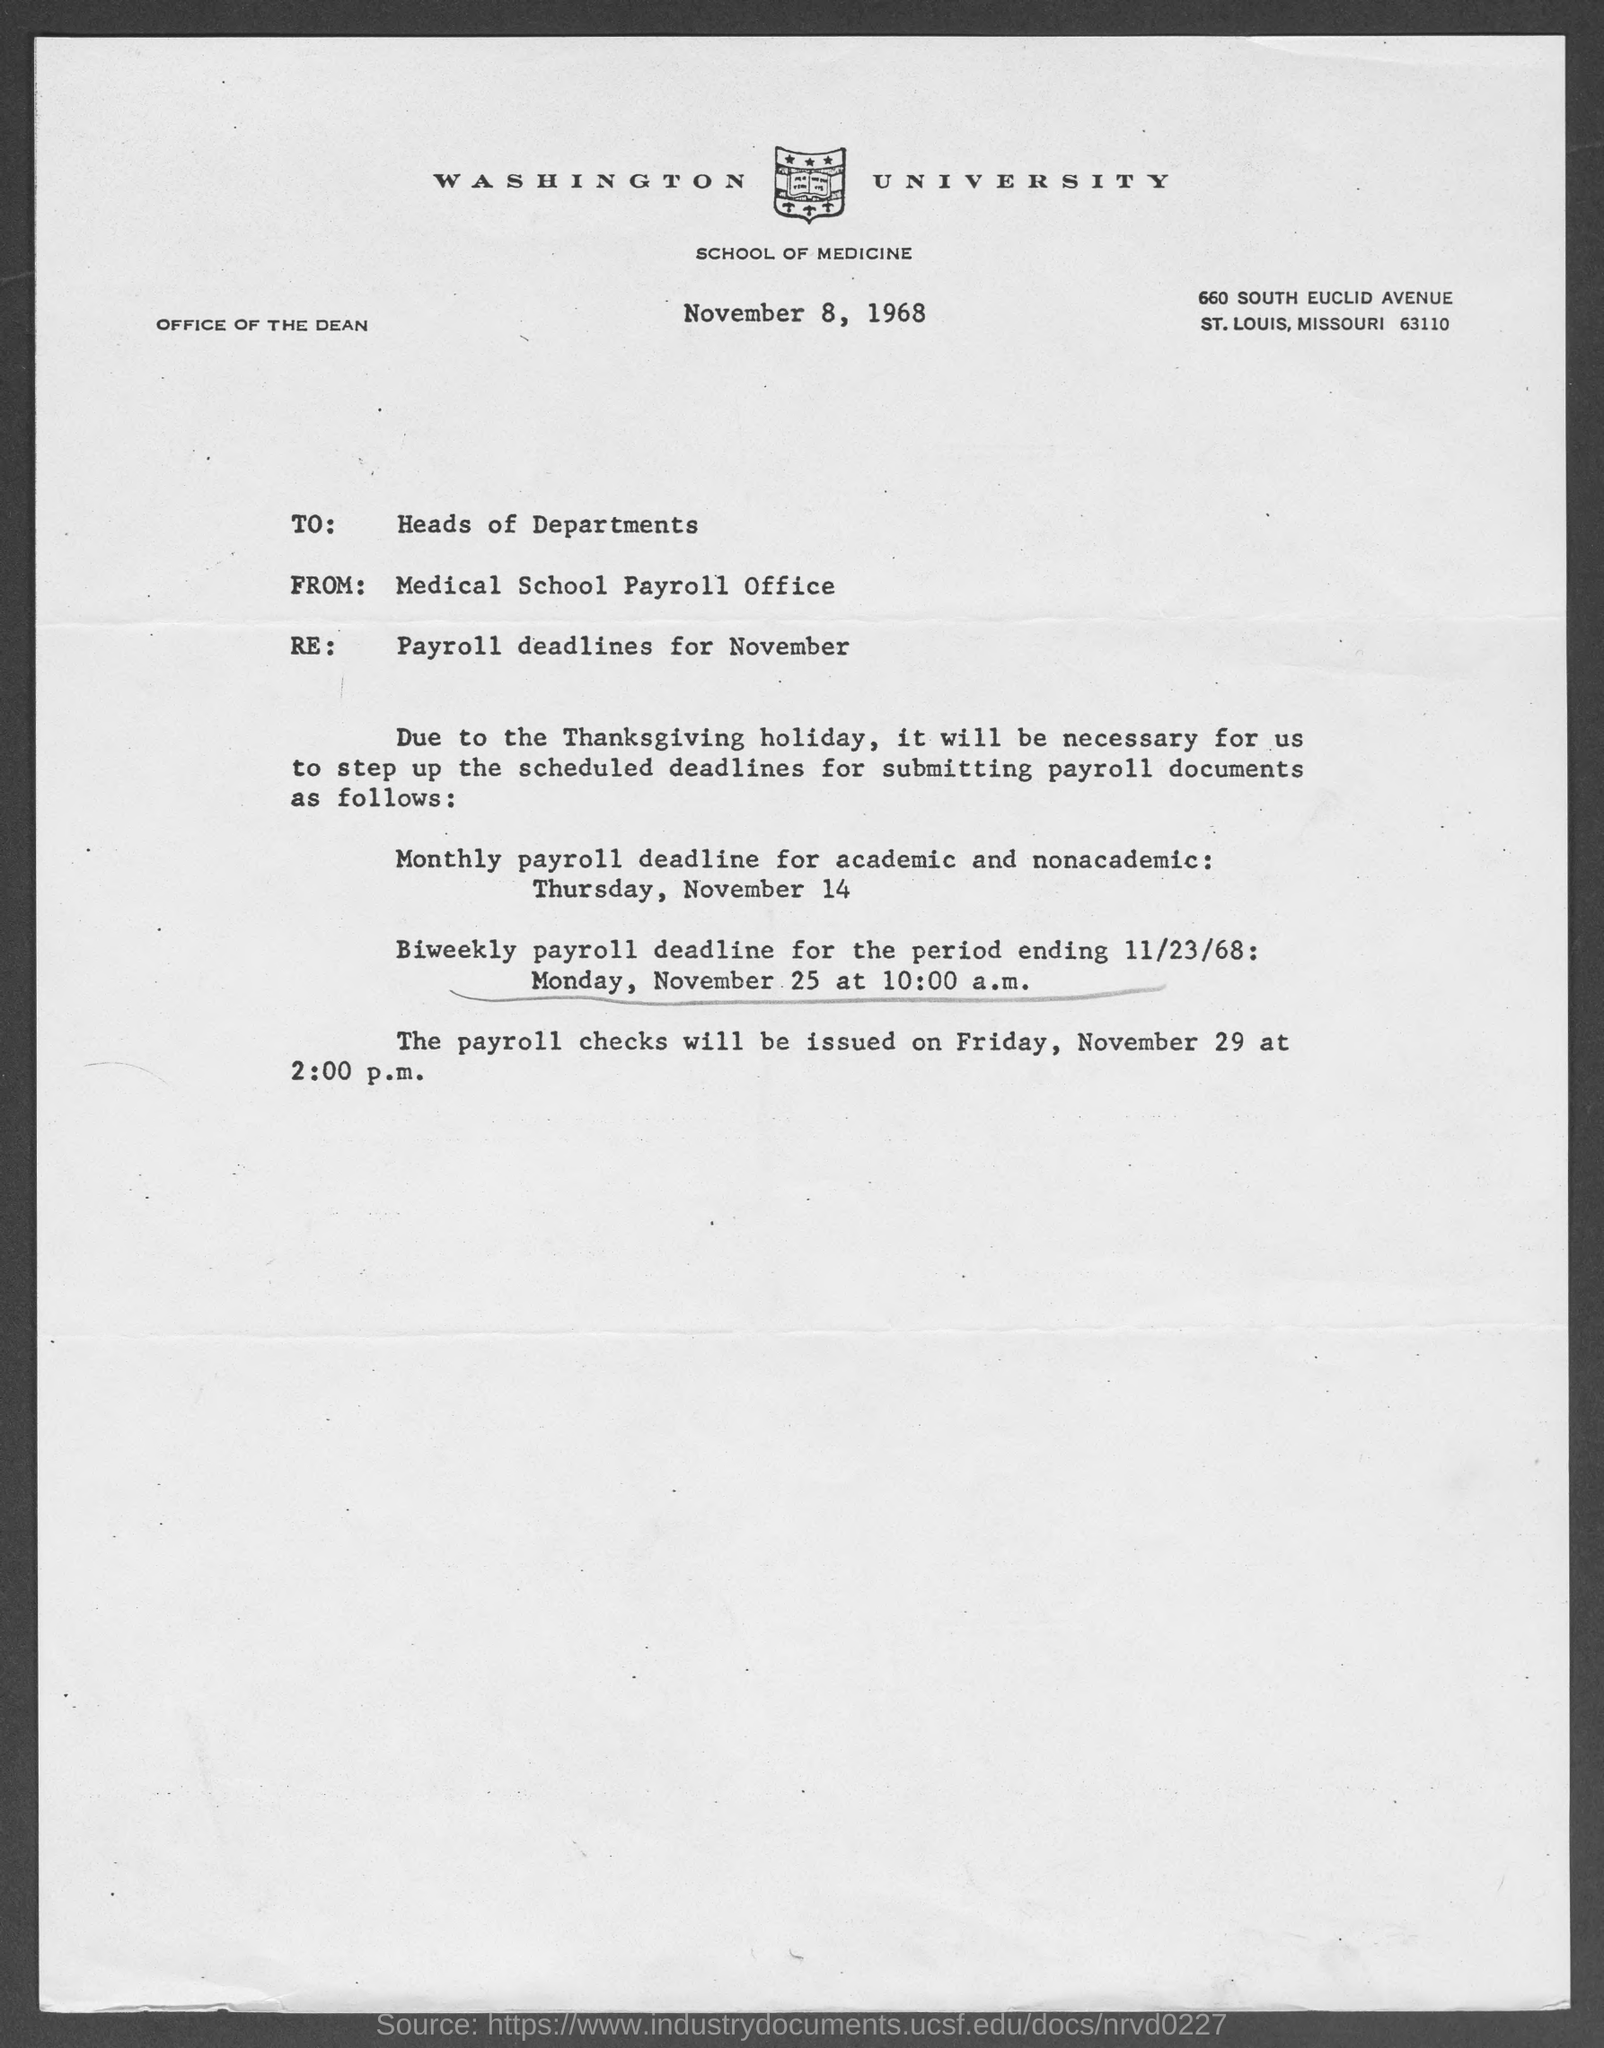Point out several critical features in this image. The monthly payroll deadline for academic and nonacademic employees is on Thursday, November 14. The letter is written to the Heads of Departments. 